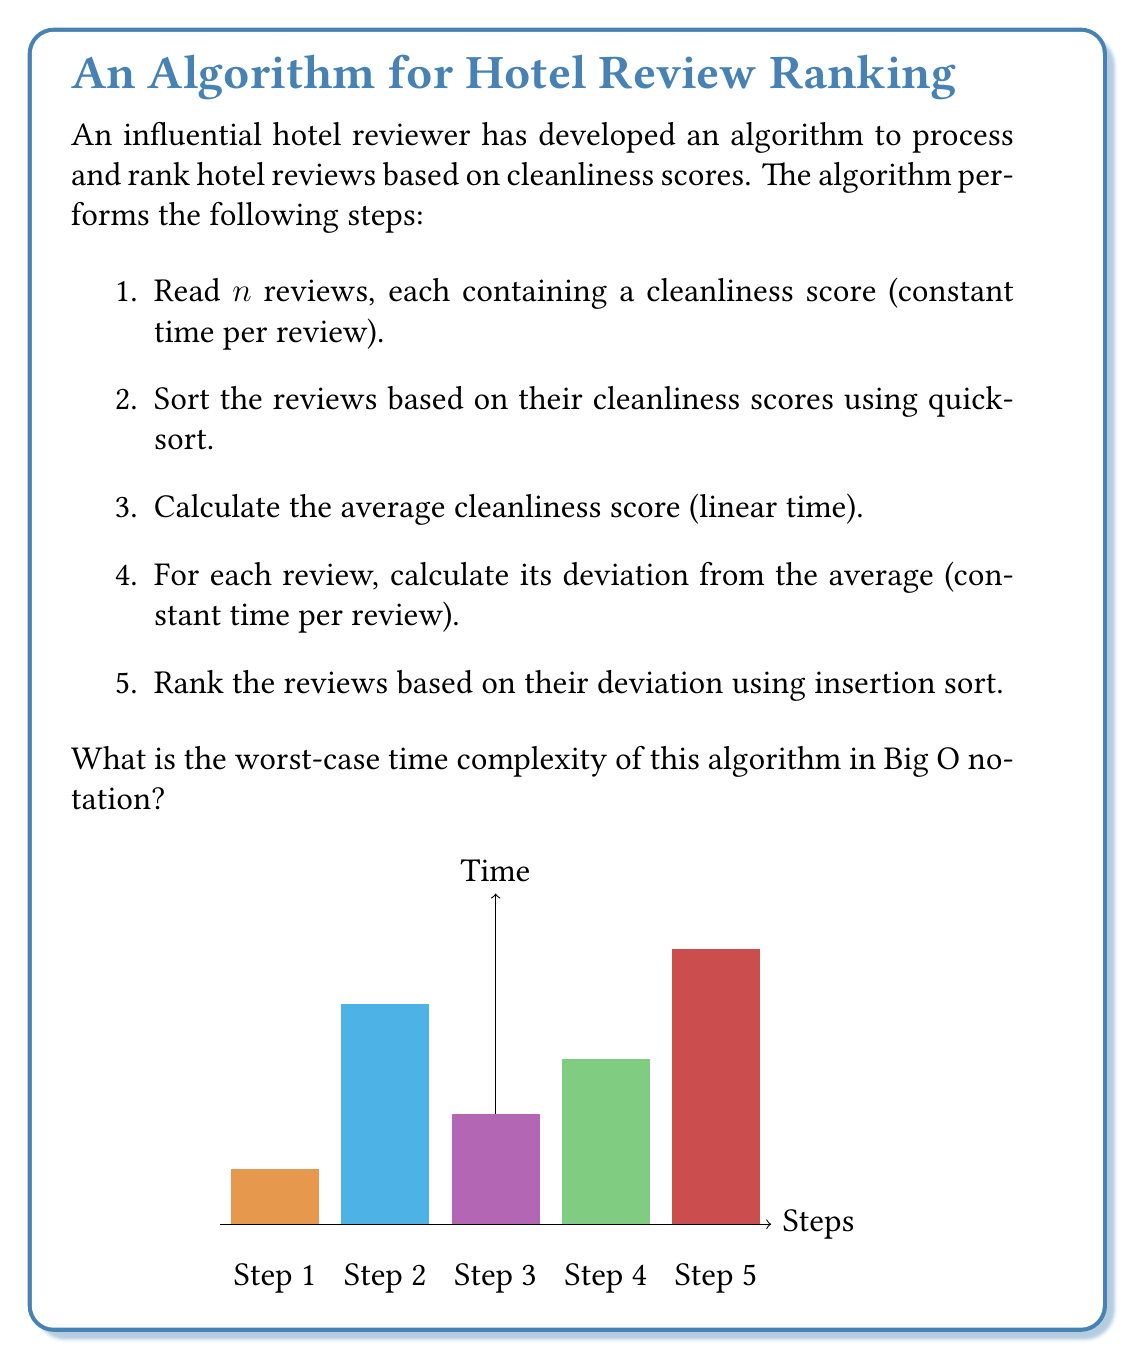Teach me how to tackle this problem. Let's analyze the time complexity of each step:

1. Reading $n$ reviews: $O(n)$
   Each review is read in constant time, so for $n$ reviews, it takes $O(n)$ time.

2. Sorting reviews using quicksort: $O(n \log n)$ on average, $O(n^2)$ in the worst case
   Quicksort has an average-case time complexity of $O(n \log n)$, but in the worst case (when the pivot is always the smallest or largest element), it can degrade to $O(n^2)$.

3. Calculating average cleanliness score: $O(n)$
   This requires summing all scores and dividing by $n$, which is a linear operation.

4. Calculating deviation for each review: $O(n)$
   This step performs a constant-time operation for each of the $n$ reviews.

5. Ranking reviews using insertion sort: $O(n^2)$
   Insertion sort has a worst-case and average-case time complexity of $O(n^2)$.

To determine the overall worst-case time complexity, we need to sum up the time complexities of all steps:

$$O(n) + O(n^2) + O(n) + O(n) + O(n^2)$$

Simplifying this expression by keeping only the dominant terms, we get:

$$O(n^2) + O(n^2) = O(n^2)$$

Therefore, the worst-case time complexity of the entire algorithm is $O(n^2)$.
Answer: $O(n^2)$ 